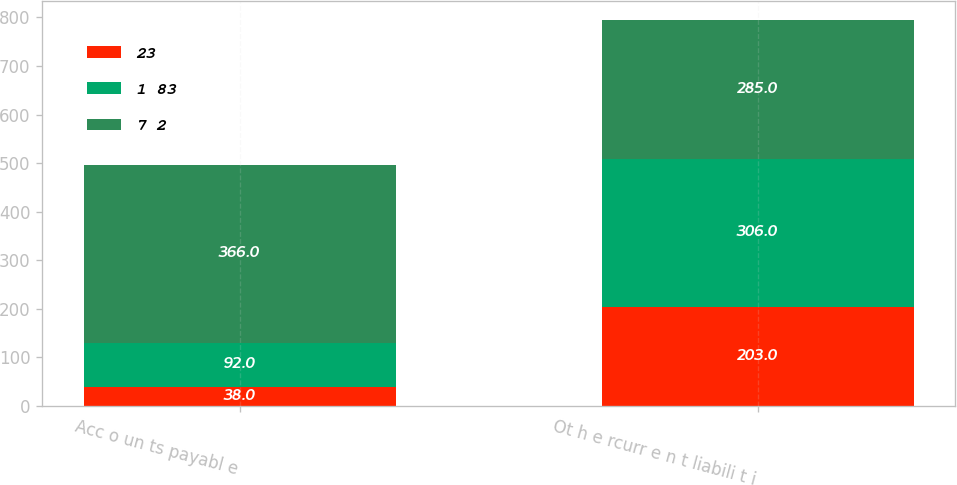Convert chart to OTSL. <chart><loc_0><loc_0><loc_500><loc_500><stacked_bar_chart><ecel><fcel>Acc o un ts payabl e<fcel>Ot h e rcurr e n t liabili t i<nl><fcel>23<fcel>38<fcel>203<nl><fcel>1 83<fcel>92<fcel>306<nl><fcel>7 2<fcel>366<fcel>285<nl></chart> 